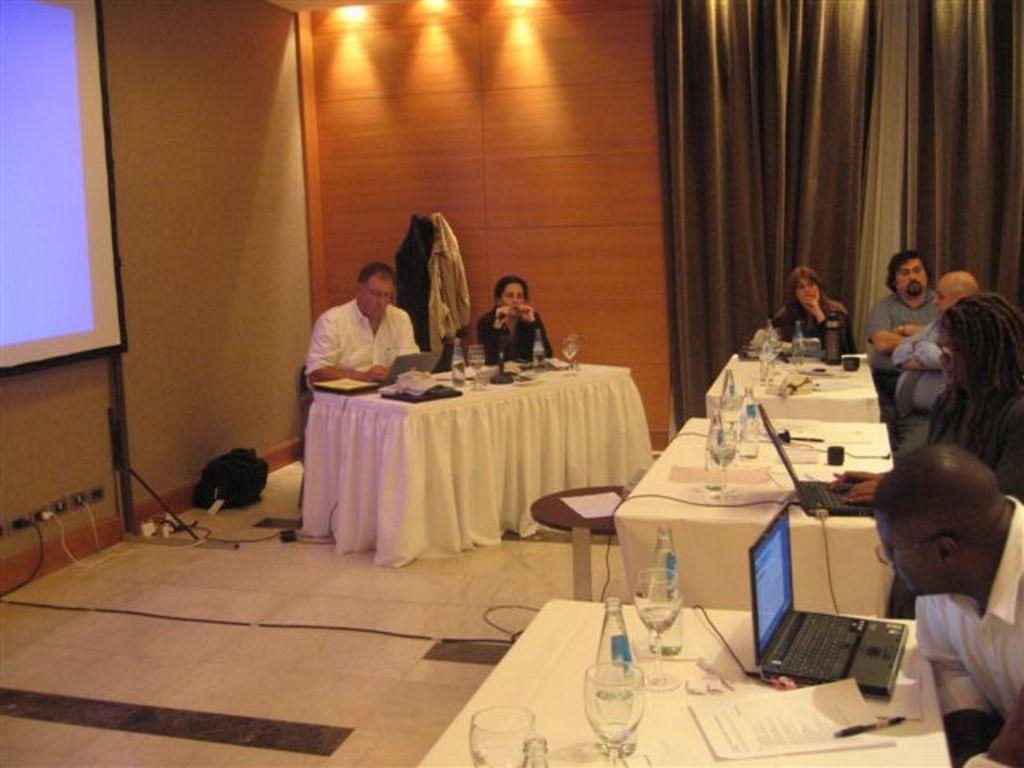In one or two sentences, can you explain what this image depicts? This image consists of tables, chairs, lights on the top,curtain on the right side top corner, screen on the left side and on the table there are glasses, bottles, laptops, papers, pens and people are sitting near the tables on chairs. 